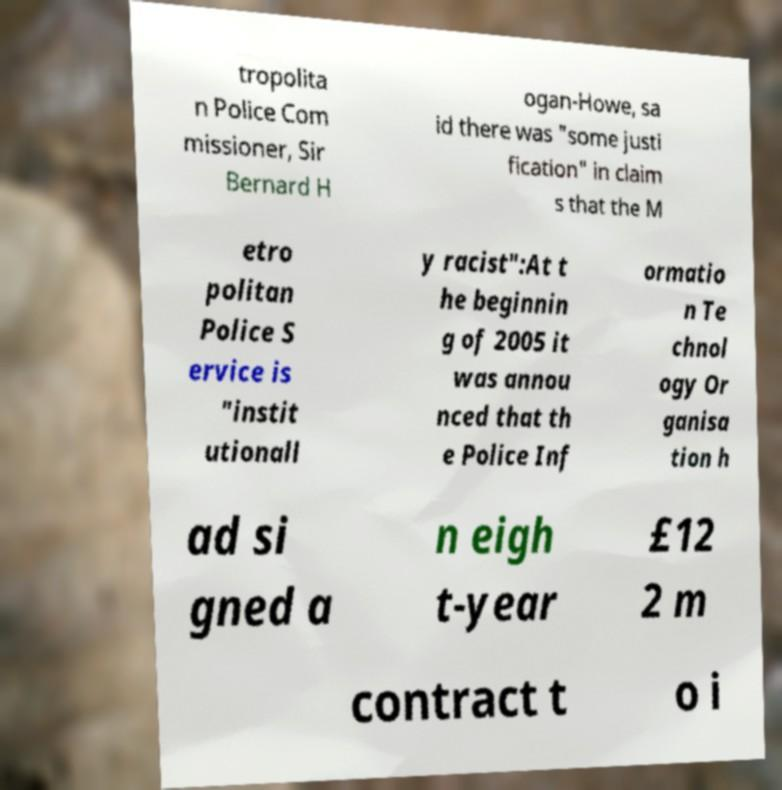For documentation purposes, I need the text within this image transcribed. Could you provide that? tropolita n Police Com missioner, Sir Bernard H ogan-Howe, sa id there was "some justi fication" in claim s that the M etro politan Police S ervice is "instit utionall y racist":At t he beginnin g of 2005 it was annou nced that th e Police Inf ormatio n Te chnol ogy Or ganisa tion h ad si gned a n eigh t-year £12 2 m contract t o i 